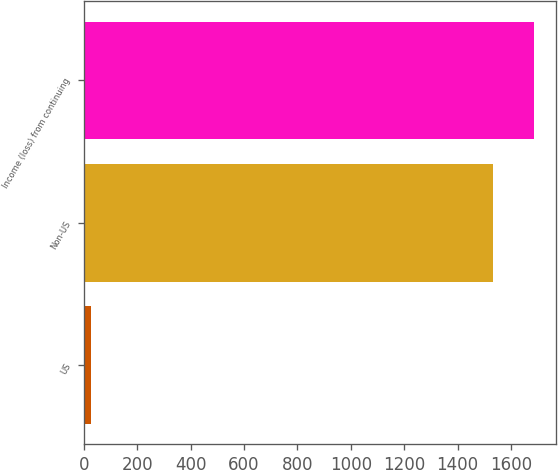Convert chart. <chart><loc_0><loc_0><loc_500><loc_500><bar_chart><fcel>US<fcel>Non-US<fcel>Income (loss) from continuing<nl><fcel>26<fcel>1532<fcel>1685.2<nl></chart> 